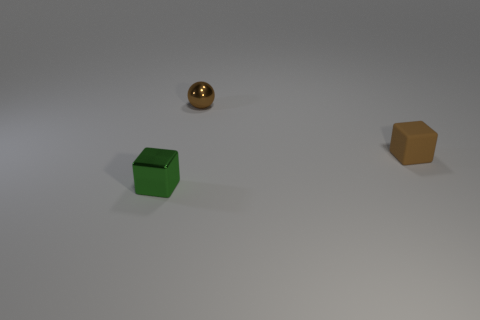There is a tiny block that is made of the same material as the small sphere; what color is it?
Make the answer very short. Green. What number of matte things are either big red cylinders or blocks?
Make the answer very short. 1. Is the material of the brown block the same as the sphere?
Provide a succinct answer. No. There is a object that is left of the metallic sphere; what shape is it?
Give a very brief answer. Cube. Is there a small green object that is behind the tiny green block that is to the left of the tiny ball?
Make the answer very short. No. Is there a blue matte cylinder that has the same size as the brown shiny sphere?
Provide a succinct answer. No. Is the color of the tiny metallic thing that is in front of the brown block the same as the small rubber object?
Offer a terse response. No. The brown cube has what size?
Your response must be concise. Small. There is a thing that is to the left of the small brown thing that is on the left side of the small rubber object; what is its size?
Give a very brief answer. Small. How many small things have the same color as the matte block?
Offer a terse response. 1. 